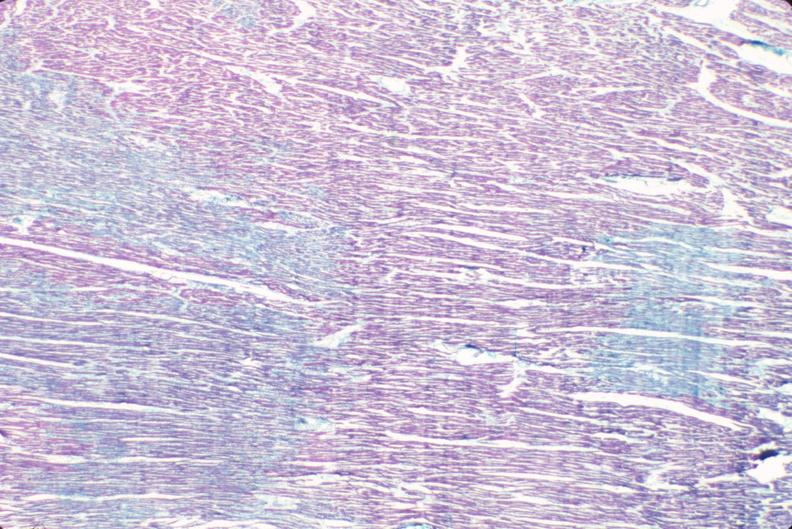do good example tastefully shown with face out of picture and genitalia stain?
Answer the question using a single word or phrase. No 